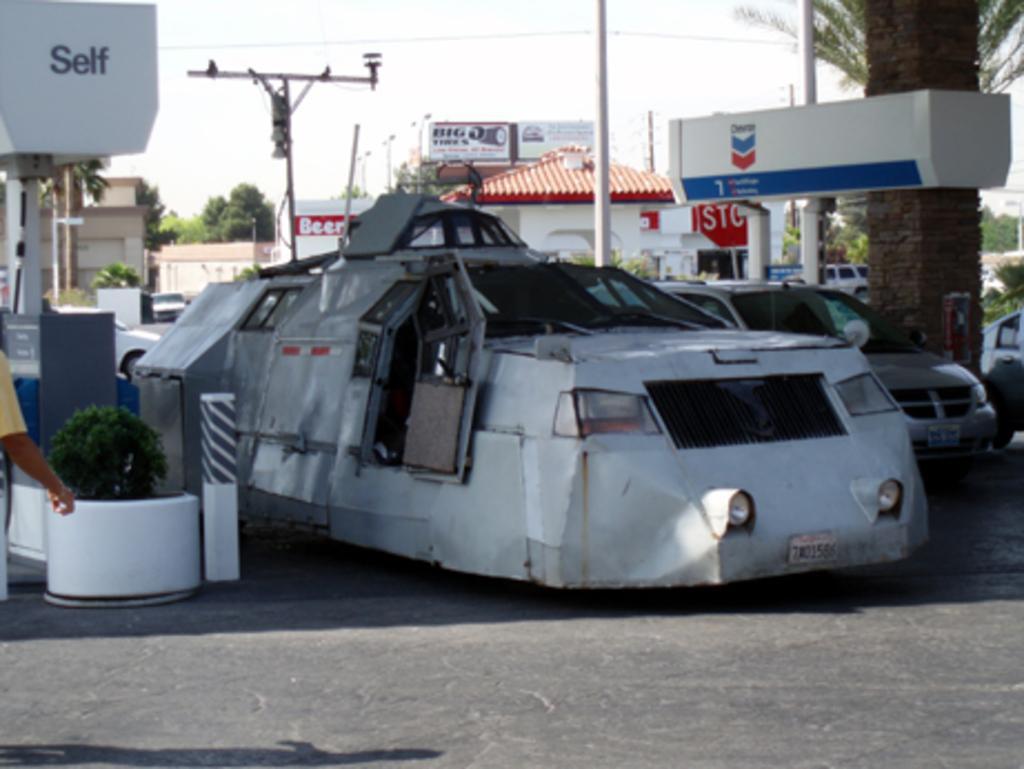Could you give a brief overview of what you see in this image? Here we can see white color damage car in the petrol pump station. Behind there is a white house with red shed and some banners. In the middle of the image we can see pole and a tree trunk. 